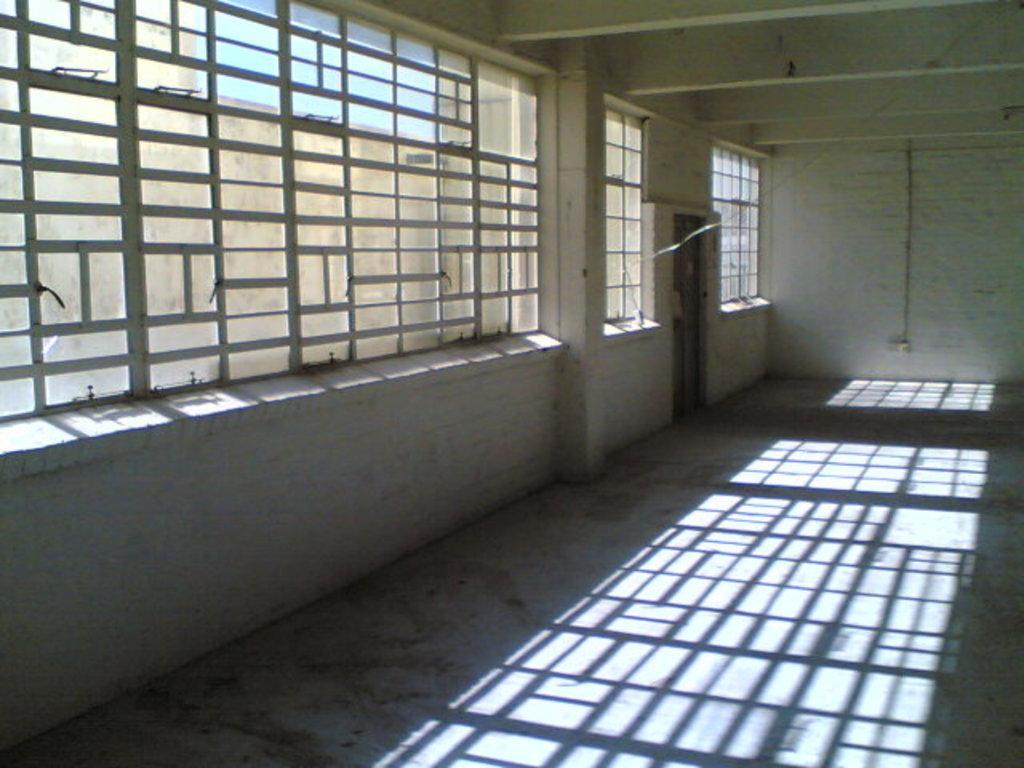How would you summarize this image in a sentence or two? In this image there are few windows and a door to the wall. This picture is taken in a room. There is a switch board attached to the wall. 